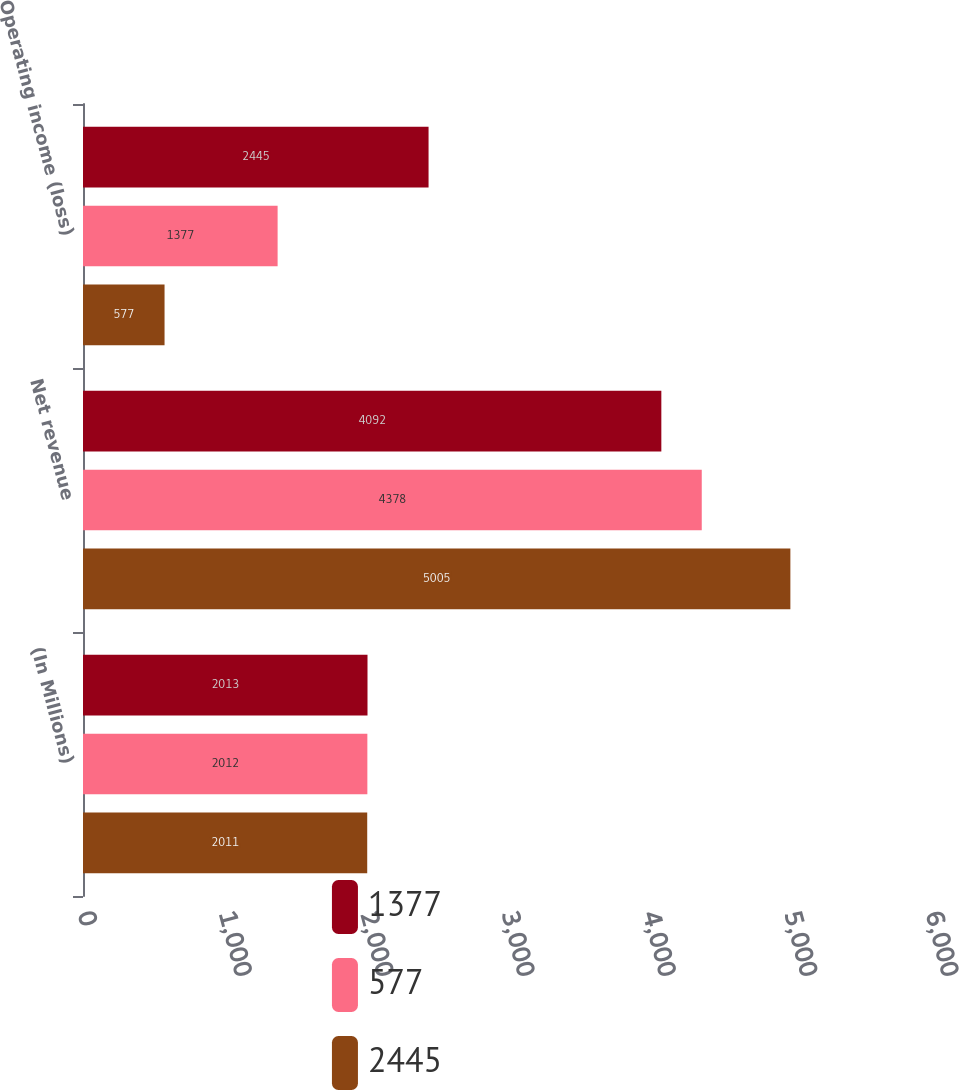<chart> <loc_0><loc_0><loc_500><loc_500><stacked_bar_chart><ecel><fcel>(In Millions)<fcel>Net revenue<fcel>Operating income (loss)<nl><fcel>1377<fcel>2013<fcel>4092<fcel>2445<nl><fcel>577<fcel>2012<fcel>4378<fcel>1377<nl><fcel>2445<fcel>2011<fcel>5005<fcel>577<nl></chart> 